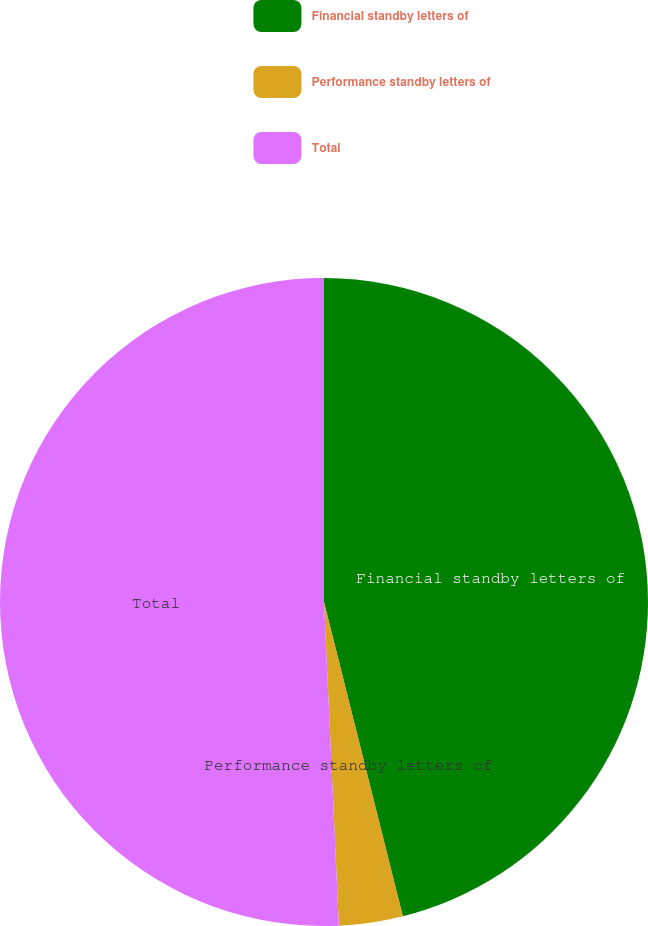Convert chart to OTSL. <chart><loc_0><loc_0><loc_500><loc_500><pie_chart><fcel>Financial standby letters of<fcel>Performance standby letters of<fcel>Total<nl><fcel>46.09%<fcel>3.18%<fcel>50.73%<nl></chart> 